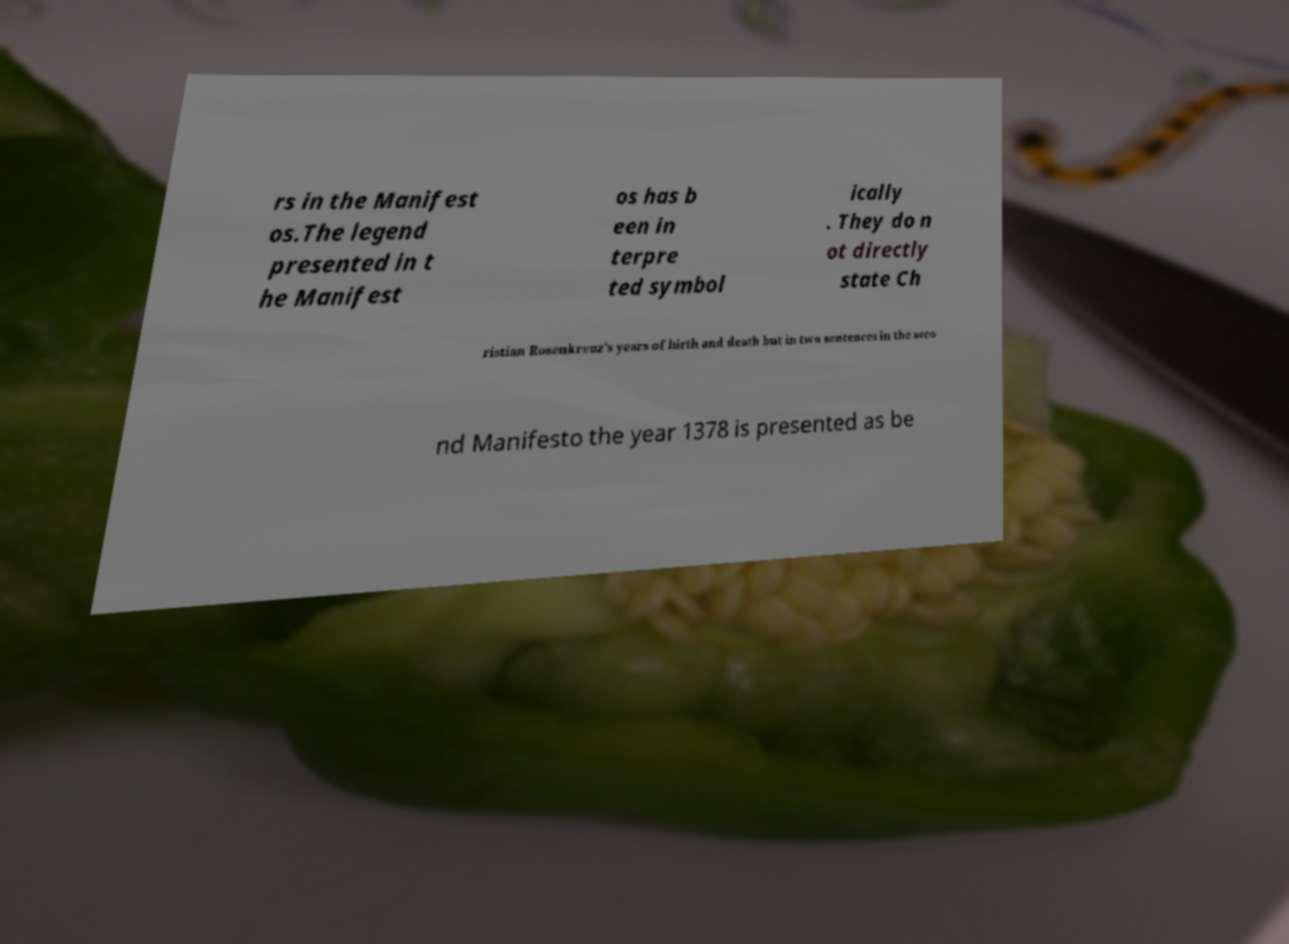Can you read and provide the text displayed in the image?This photo seems to have some interesting text. Can you extract and type it out for me? rs in the Manifest os.The legend presented in t he Manifest os has b een in terpre ted symbol ically . They do n ot directly state Ch ristian Rosenkreuz's years of birth and death but in two sentences in the seco nd Manifesto the year 1378 is presented as be 